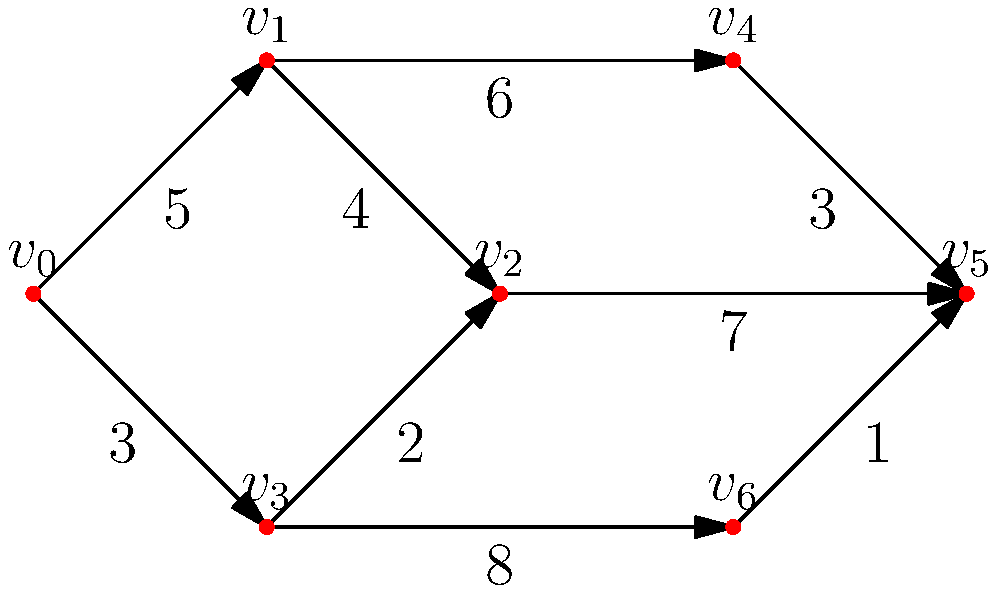Given the weighted directed graph representing a city road network, where vertices represent intersections and edge weights represent travel times in minutes, what is the minimum time required to travel from intersection $v_0$ to intersection $v_5$? Additionally, what path should be taken to achieve this minimum time? To solve this problem, we'll use Dijkstra's algorithm to find the shortest path from $v_0$ to $v_5$. Here's a step-by-step explanation:

1) Initialize distances: Set distance to $v_0$ as 0 and all others as infinity.
   $d(v_0) = 0$, $d(v_1) = d(v_2) = d(v_3) = d(v_4) = d(v_5) = d(v_6) = \infty$

2) Start from $v_0$:
   - Update $d(v_1) = 5$ and $d(v_3) = 3$

3) Select vertex with minimum distance (excluding visited): $v_3$
   - Update $d(v_2) = \min(d(v_2), d(v_3) + 2) = 5$
   - Update $d(v_6) = \min(d(v_6), d(v_3) + 8) = 11$

4) Select next minimum: $v_1$
   - Update $d(v_2) = \min(d(v_2), d(v_1) + 4) = 5$ (no change)
   - Update $d(v_4) = \min(d(v_4), d(v_1) + 6) = 11$

5) Select next minimum: $v_2$
   - Update $d(v_5) = \min(d(v_5), d(v_2) + 7) = 12$

6) Select next minimum: $v_4$
   - Update $d(v_5) = \min(d(v_5), d(v_4) + 3) = 11$

7) Select next minimum: $v_6$
   - Update $d(v_5) = \min(d(v_5), d(v_6) + 1) = 11$ (no change)

The minimum time to reach $v_5$ from $v_0$ is 11 minutes.

To find the path, we backtrack from $v_5$:
$v_5 \leftarrow v_4 \leftarrow v_1 \leftarrow v_0$

Therefore, the optimal path is $v_0 \rightarrow v_1 \rightarrow v_4 \rightarrow v_5$.
Answer: 11 minutes; Path: $v_0 \rightarrow v_1 \rightarrow v_4 \rightarrow v_5$ 